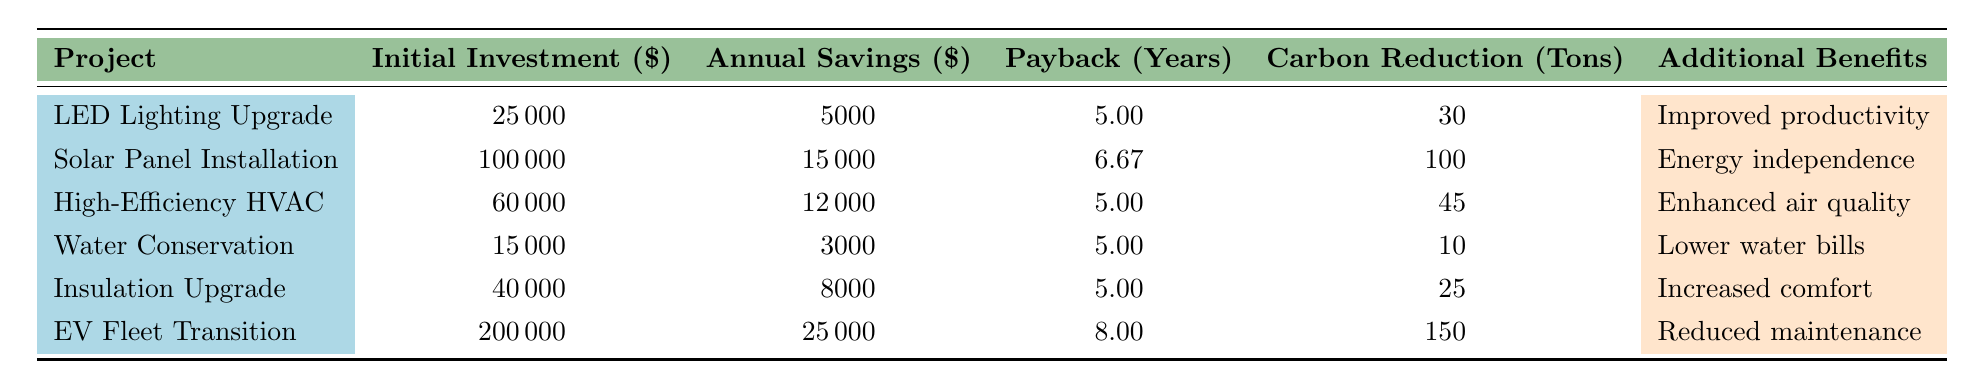What is the initial investment for the Solar Panel Installation project? The initial investment for this project is stated directly in the table under the "Initial Investment" column corresponding to the "Solar Panel Installation" row. The value is 100000 dollars.
Answer: 100000 How much annual savings does the High-Efficiency HVAC System provide? The table lists the annual savings for the High-Efficiency HVAC System in the "Annual Savings" column. The value is 12000 dollars.
Answer: 12000 What is the payback period for the Water Conservation System? The payback period is indicated in the "Payback (Years)" column for the Water Conservation System row. The value is 5.00 years.
Answer: 5.00 Which project has the highest carbon reduction, and how much is it? By reviewing the "Carbon Reduction (Tons)" column, the Electric Vehicle Fleet Transition has the highest carbon reduction at 150 tons.
Answer: Electric Vehicle Fleet Transition, 150 tons What is the average annual savings across all projects? To find the average, sum the annual savings for all projects: 5000 + 15000 + 12000 + 3000 + 8000 + 25000 = 68000. There are 6 projects, so the average is 68000 divided by 6, which equals 11333.33 dollars.
Answer: 11333.33 Is the initial investment for the LED Lighting Upgrade less than 30000 dollars? The initial investment for the LED Lighting Upgrade project is 25000 dollars, which is indeed less than 30000 dollars.
Answer: Yes How does the payback period of the Solar Panel Installation compare to that of the High-Efficiency HVAC System? The payback period for the Solar Panel Installation is 6.67 years, while for the High-Efficiency HVAC System, it is 5.00 years. Since 6.67 is greater than 5.00, the Solar Panel Installation has a longer payback period.
Answer: Longer What is the total initial investment of all projects combined? The total initial investment is calculated by adding all the initial investments: 25000 + 100000 + 60000 + 15000 + 40000 + 200000 = 320000 dollars.
Answer: 320000 Which project has the best annual savings to initial investment ratio? First, calculate the ratio for each project. For example, for the LED Lighting Upgrade: 5000/25000 = 0.2, for the Solar Panel Installation: 15000/100000 = 0.15. Continuing this, we find that the Water Conservation System has a ratio of 3000/15000 = 0.2 which is equal to the LED Lighting Upgrade, with both having the best ratio of 0.2.
Answer: LED Lighting Upgrade and Water Conservation System, 0.2 If we consider only the projects with a payback of 5 years, which project has the highest carbon reduction? The projects with a payback period of 5 years are LED Lighting Upgrade, High-Efficiency HVAC System, Water Conservation System, and Building Insulation Upgrade. Their carbon reductions are 30, 45, 10, and 25 tons respectively. The highest reduction is from the High-Efficiency HVAC System with 45 tons.
Answer: High-Efficiency HVAC System, 45 tons 